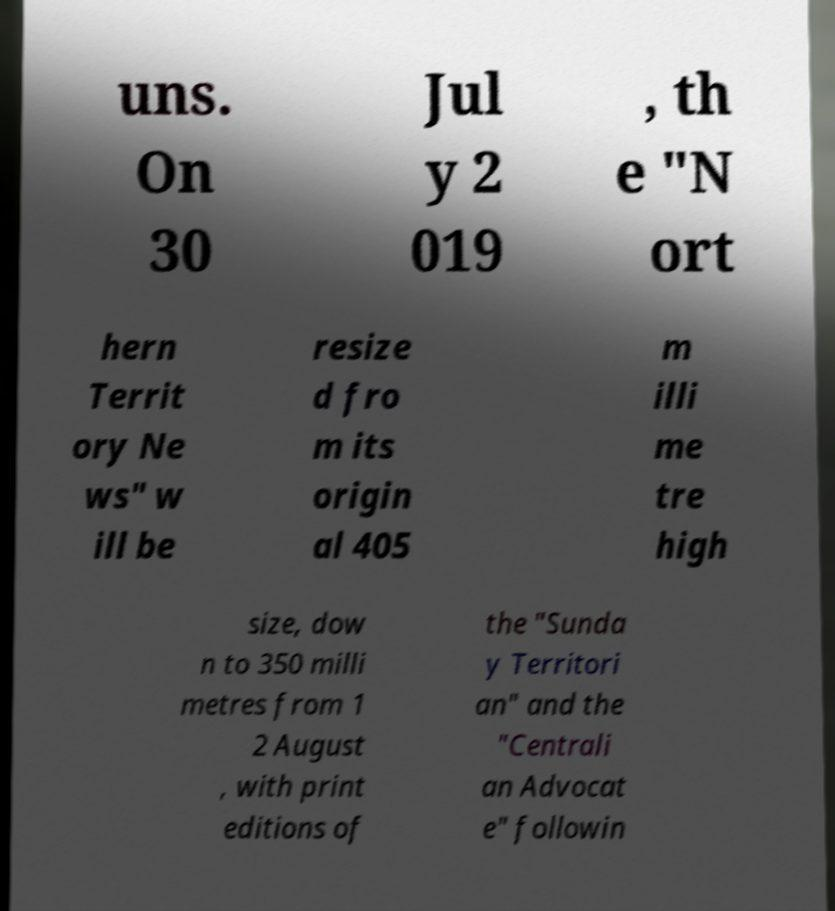Can you accurately transcribe the text from the provided image for me? uns. On 30 Jul y 2 019 , th e "N ort hern Territ ory Ne ws" w ill be resize d fro m its origin al 405 m illi me tre high size, dow n to 350 milli metres from 1 2 August , with print editions of the "Sunda y Territori an" and the "Centrali an Advocat e" followin 